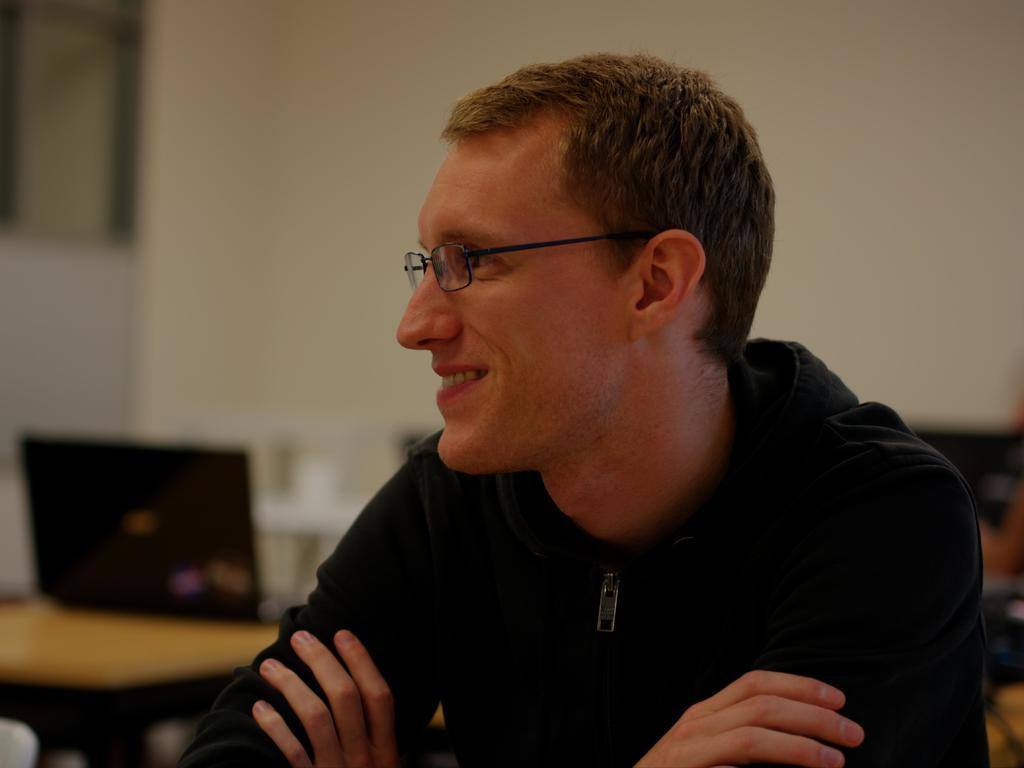Who is present in the image? There is a man in the image. What is the man doing in the image? The man is smiling in the image. What is the man wearing in the image? The man is wearing a black color hoodie in the image. What object can be seen on a table in the image? There is a laptop on a table in the image. What type of base is the man using to support his laptop in the image? There is no base mentioned or visible in the image for the laptop; it is simply placed on a table. Is the man's grandmother present in the image? There is no mention or indication of a grandmother in the image. 